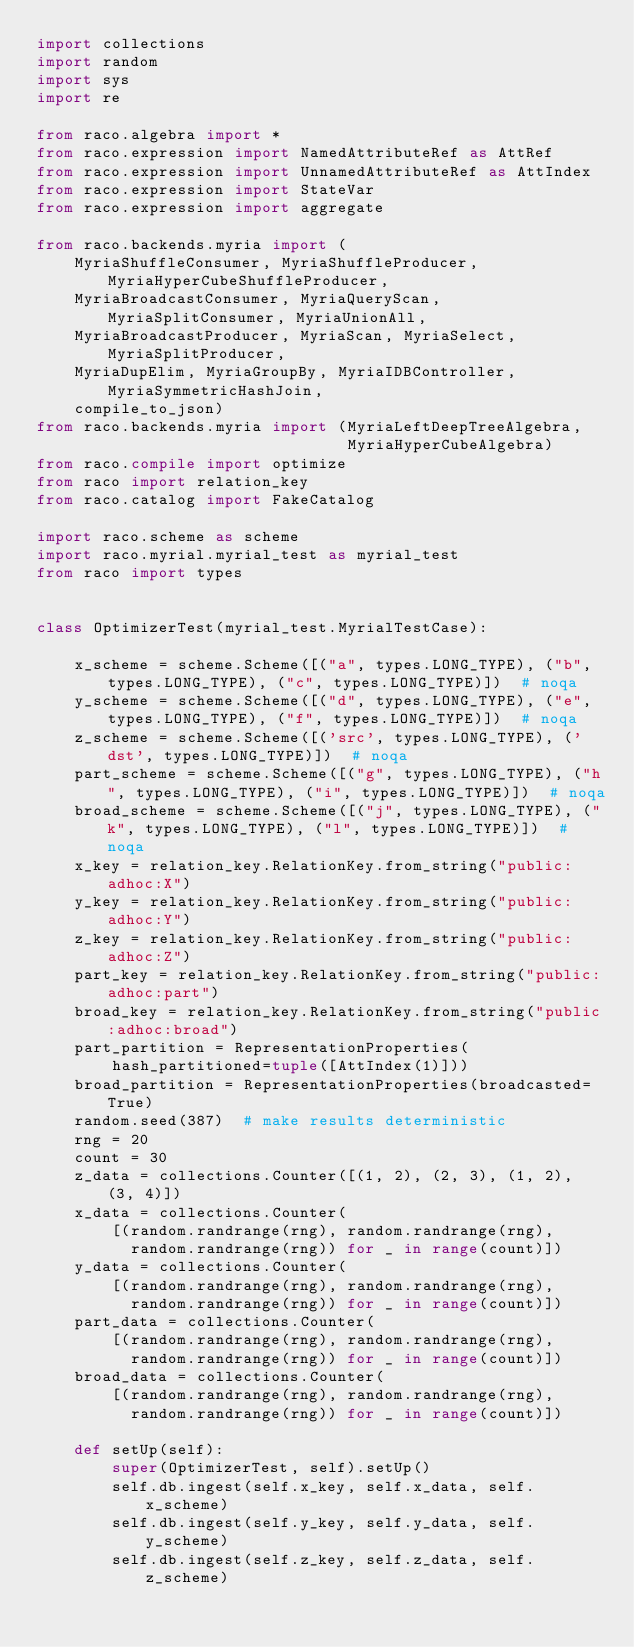<code> <loc_0><loc_0><loc_500><loc_500><_Python_>import collections
import random
import sys
import re

from raco.algebra import *
from raco.expression import NamedAttributeRef as AttRef
from raco.expression import UnnamedAttributeRef as AttIndex
from raco.expression import StateVar
from raco.expression import aggregate

from raco.backends.myria import (
    MyriaShuffleConsumer, MyriaShuffleProducer, MyriaHyperCubeShuffleProducer,
    MyriaBroadcastConsumer, MyriaQueryScan, MyriaSplitConsumer, MyriaUnionAll,
    MyriaBroadcastProducer, MyriaScan, MyriaSelect, MyriaSplitProducer,
    MyriaDupElim, MyriaGroupBy, MyriaIDBController, MyriaSymmetricHashJoin,
    compile_to_json)
from raco.backends.myria import (MyriaLeftDeepTreeAlgebra,
                                 MyriaHyperCubeAlgebra)
from raco.compile import optimize
from raco import relation_key
from raco.catalog import FakeCatalog

import raco.scheme as scheme
import raco.myrial.myrial_test as myrial_test
from raco import types


class OptimizerTest(myrial_test.MyrialTestCase):

    x_scheme = scheme.Scheme([("a", types.LONG_TYPE), ("b", types.LONG_TYPE), ("c", types.LONG_TYPE)])  # noqa
    y_scheme = scheme.Scheme([("d", types.LONG_TYPE), ("e", types.LONG_TYPE), ("f", types.LONG_TYPE)])  # noqa
    z_scheme = scheme.Scheme([('src', types.LONG_TYPE), ('dst', types.LONG_TYPE)])  # noqa
    part_scheme = scheme.Scheme([("g", types.LONG_TYPE), ("h", types.LONG_TYPE), ("i", types.LONG_TYPE)])  # noqa
    broad_scheme = scheme.Scheme([("j", types.LONG_TYPE), ("k", types.LONG_TYPE), ("l", types.LONG_TYPE)])  # noqa
    x_key = relation_key.RelationKey.from_string("public:adhoc:X")
    y_key = relation_key.RelationKey.from_string("public:adhoc:Y")
    z_key = relation_key.RelationKey.from_string("public:adhoc:Z")
    part_key = relation_key.RelationKey.from_string("public:adhoc:part")
    broad_key = relation_key.RelationKey.from_string("public:adhoc:broad")
    part_partition = RepresentationProperties(
        hash_partitioned=tuple([AttIndex(1)]))
    broad_partition = RepresentationProperties(broadcasted=True)
    random.seed(387)  # make results deterministic
    rng = 20
    count = 30
    z_data = collections.Counter([(1, 2), (2, 3), (1, 2), (3, 4)])
    x_data = collections.Counter(
        [(random.randrange(rng), random.randrange(rng),
          random.randrange(rng)) for _ in range(count)])
    y_data = collections.Counter(
        [(random.randrange(rng), random.randrange(rng),
          random.randrange(rng)) for _ in range(count)])
    part_data = collections.Counter(
        [(random.randrange(rng), random.randrange(rng),
          random.randrange(rng)) for _ in range(count)])
    broad_data = collections.Counter(
        [(random.randrange(rng), random.randrange(rng),
          random.randrange(rng)) for _ in range(count)])

    def setUp(self):
        super(OptimizerTest, self).setUp()
        self.db.ingest(self.x_key, self.x_data, self.x_scheme)
        self.db.ingest(self.y_key, self.y_data, self.y_scheme)
        self.db.ingest(self.z_key, self.z_data, self.z_scheme)</code> 